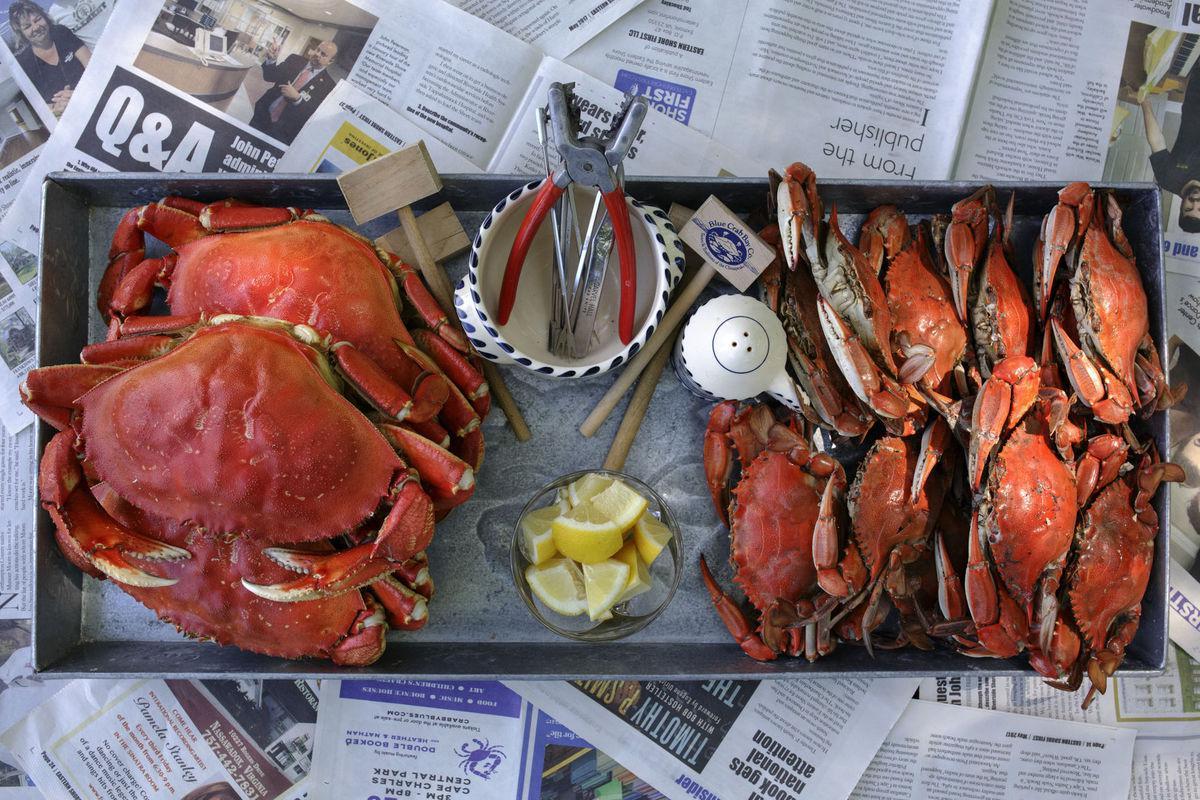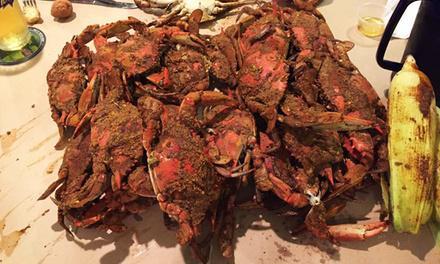The first image is the image on the left, the second image is the image on the right. Given the left and right images, does the statement "No image contains more than two crabs, and no image features crabs that are prepared for eating." hold true? Answer yes or no. No. 